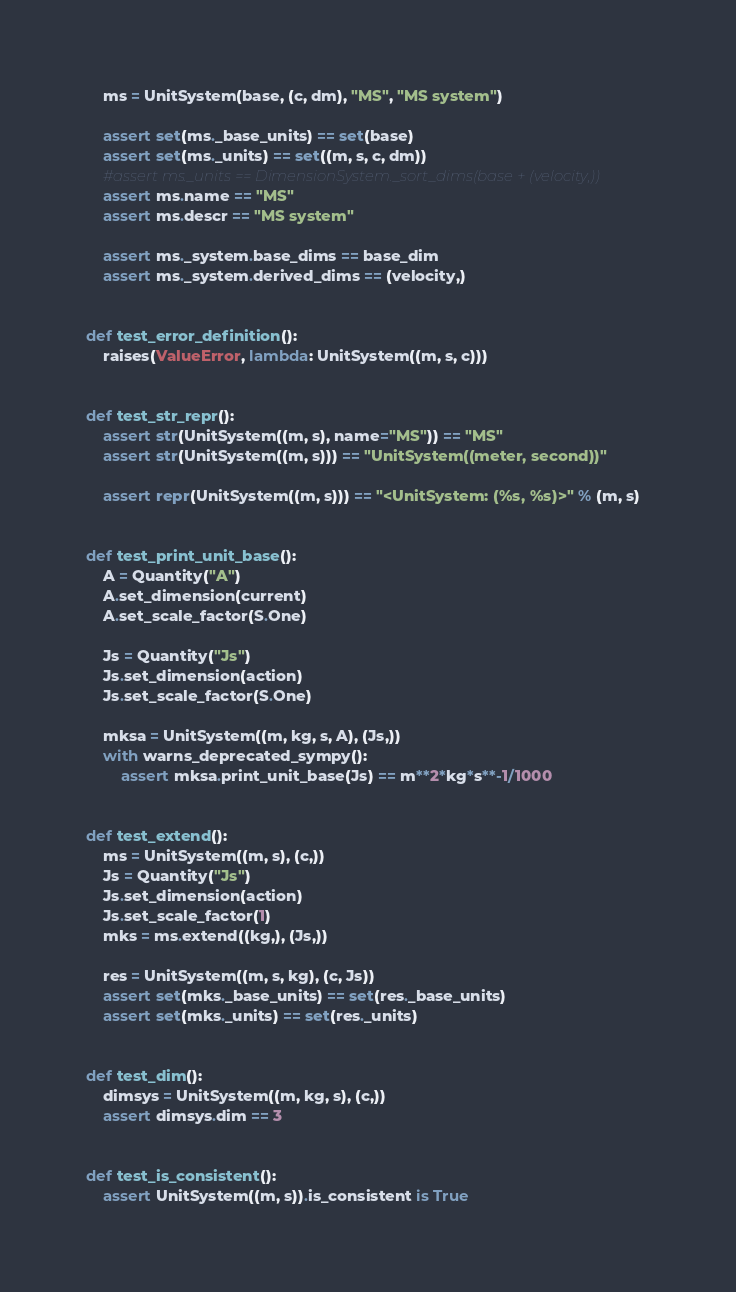Convert code to text. <code><loc_0><loc_0><loc_500><loc_500><_Python_>    ms = UnitSystem(base, (c, dm), "MS", "MS system")

    assert set(ms._base_units) == set(base)
    assert set(ms._units) == set((m, s, c, dm))
    #assert ms._units == DimensionSystem._sort_dims(base + (velocity,))
    assert ms.name == "MS"
    assert ms.descr == "MS system"

    assert ms._system.base_dims == base_dim
    assert ms._system.derived_dims == (velocity,)


def test_error_definition():
    raises(ValueError, lambda: UnitSystem((m, s, c)))


def test_str_repr():
    assert str(UnitSystem((m, s), name="MS")) == "MS"
    assert str(UnitSystem((m, s))) == "UnitSystem((meter, second))"

    assert repr(UnitSystem((m, s))) == "<UnitSystem: (%s, %s)>" % (m, s)


def test_print_unit_base():
    A = Quantity("A")
    A.set_dimension(current)
    A.set_scale_factor(S.One)

    Js = Quantity("Js")
    Js.set_dimension(action)
    Js.set_scale_factor(S.One)

    mksa = UnitSystem((m, kg, s, A), (Js,))
    with warns_deprecated_sympy():
        assert mksa.print_unit_base(Js) == m**2*kg*s**-1/1000


def test_extend():
    ms = UnitSystem((m, s), (c,))
    Js = Quantity("Js")
    Js.set_dimension(action)
    Js.set_scale_factor(1)
    mks = ms.extend((kg,), (Js,))

    res = UnitSystem((m, s, kg), (c, Js))
    assert set(mks._base_units) == set(res._base_units)
    assert set(mks._units) == set(res._units)


def test_dim():
    dimsys = UnitSystem((m, kg, s), (c,))
    assert dimsys.dim == 3


def test_is_consistent():
    assert UnitSystem((m, s)).is_consistent is True
</code> 